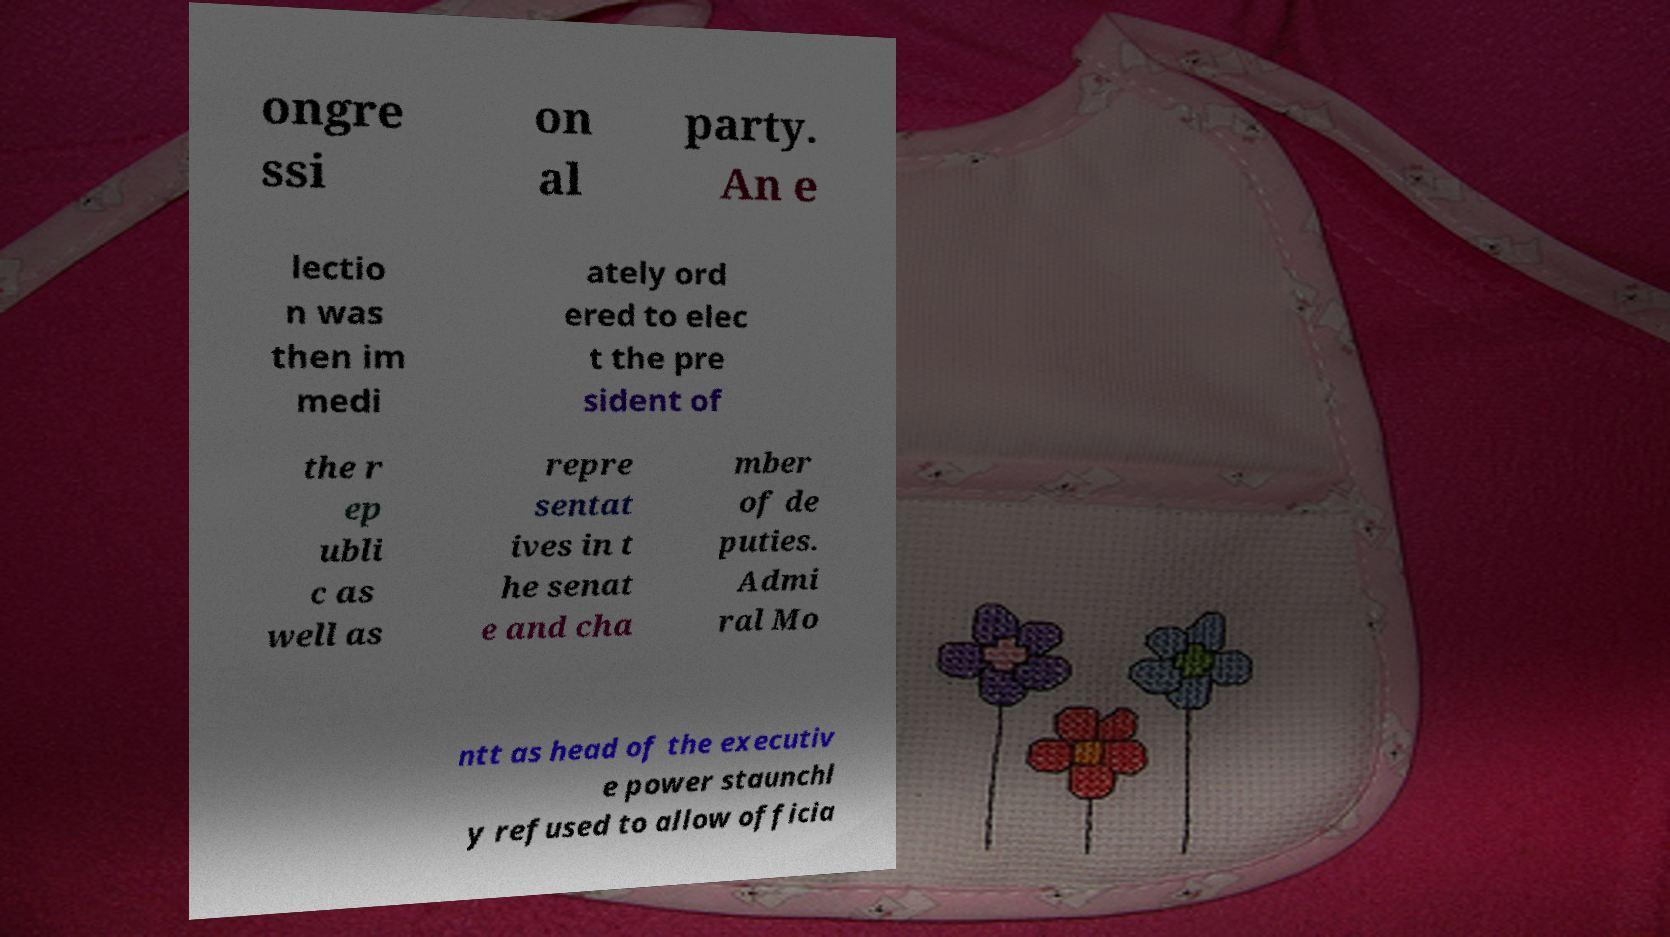There's text embedded in this image that I need extracted. Can you transcribe it verbatim? ongre ssi on al party. An e lectio n was then im medi ately ord ered to elec t the pre sident of the r ep ubli c as well as repre sentat ives in t he senat e and cha mber of de puties. Admi ral Mo ntt as head of the executiv e power staunchl y refused to allow officia 